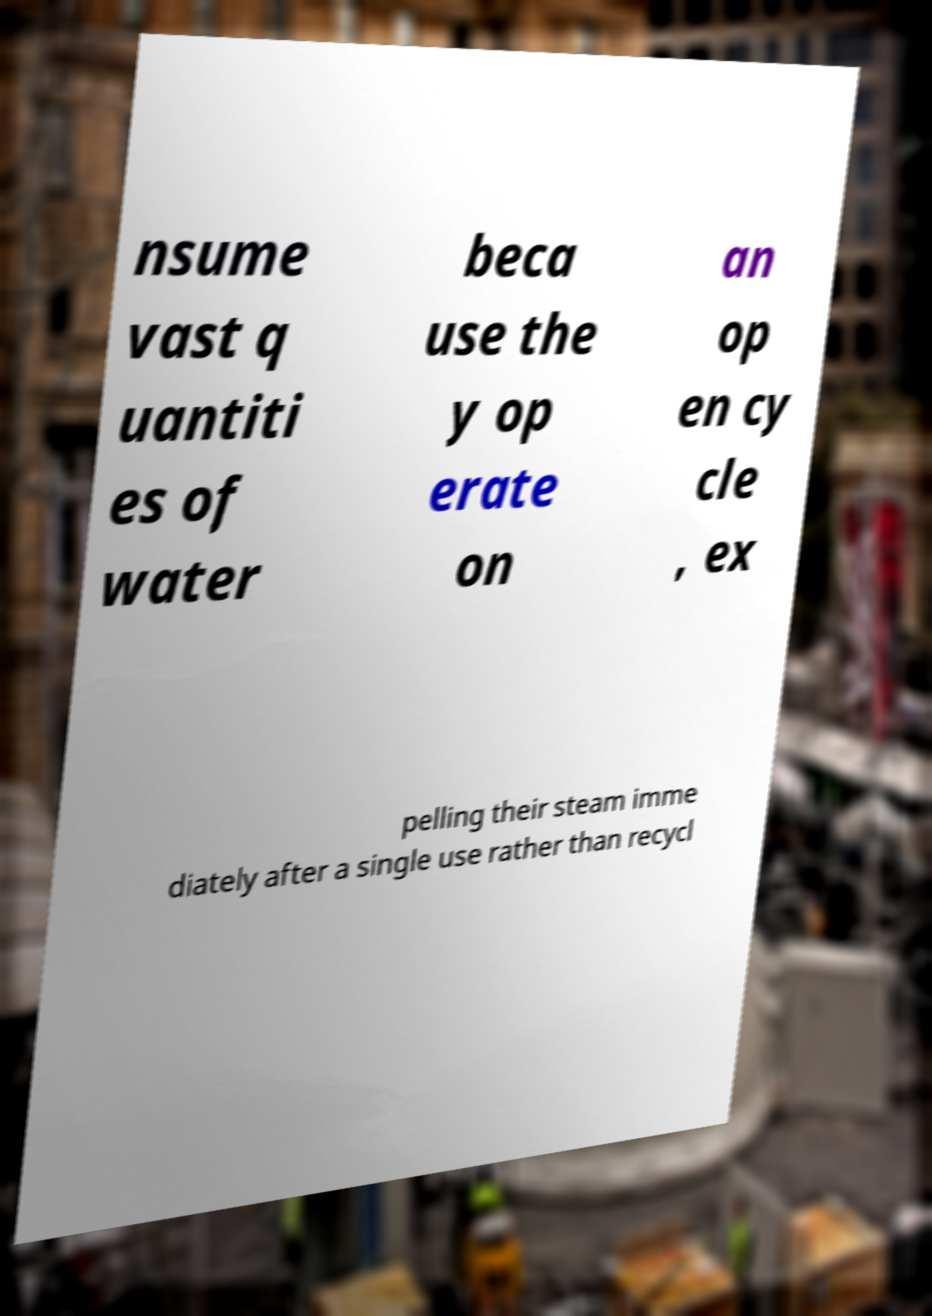There's text embedded in this image that I need extracted. Can you transcribe it verbatim? nsume vast q uantiti es of water beca use the y op erate on an op en cy cle , ex pelling their steam imme diately after a single use rather than recycl 